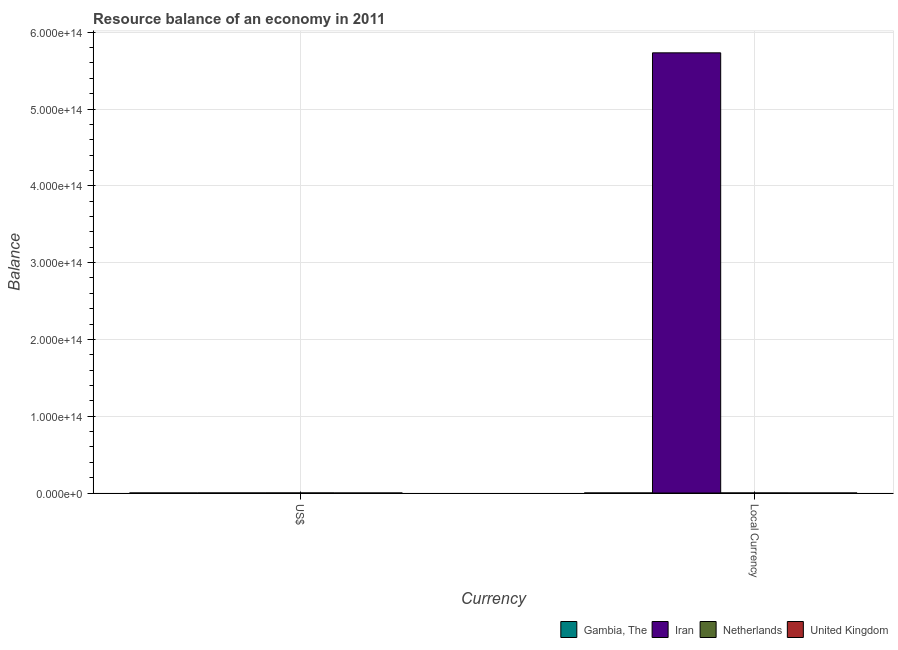How many different coloured bars are there?
Your answer should be very brief. 2. Are the number of bars per tick equal to the number of legend labels?
Your response must be concise. No. Are the number of bars on each tick of the X-axis equal?
Your answer should be compact. Yes. How many bars are there on the 1st tick from the left?
Give a very brief answer. 2. How many bars are there on the 1st tick from the right?
Your answer should be very brief. 2. What is the label of the 2nd group of bars from the left?
Offer a terse response. Local Currency. What is the resource balance in us$ in United Kingdom?
Give a very brief answer. 0. Across all countries, what is the maximum resource balance in constant us$?
Your answer should be compact. 5.73e+14. Across all countries, what is the minimum resource balance in constant us$?
Your response must be concise. 0. What is the total resource balance in constant us$ in the graph?
Offer a terse response. 5.73e+14. What is the difference between the resource balance in us$ in Iran and that in Netherlands?
Offer a very short reply. -2.23e+1. What is the difference between the resource balance in constant us$ in Netherlands and the resource balance in us$ in United Kingdom?
Provide a short and direct response. 5.49e+1. What is the average resource balance in constant us$ per country?
Your response must be concise. 1.43e+14. What is the difference between the resource balance in us$ and resource balance in constant us$ in Iran?
Your answer should be very brief. -5.73e+14. In how many countries, is the resource balance in us$ greater than 560000000000000 units?
Your answer should be compact. 0. What is the ratio of the resource balance in constant us$ in Iran to that in Netherlands?
Offer a very short reply. 1.04e+04. Are all the bars in the graph horizontal?
Make the answer very short. No. How many countries are there in the graph?
Give a very brief answer. 4. What is the difference between two consecutive major ticks on the Y-axis?
Offer a very short reply. 1.00e+14. Does the graph contain grids?
Offer a very short reply. Yes. How many legend labels are there?
Offer a terse response. 4. How are the legend labels stacked?
Provide a succinct answer. Horizontal. What is the title of the graph?
Provide a short and direct response. Resource balance of an economy in 2011. What is the label or title of the X-axis?
Ensure brevity in your answer.  Currency. What is the label or title of the Y-axis?
Your answer should be very brief. Balance. What is the Balance in Iran in US$?
Provide a succinct answer. 5.40e+1. What is the Balance of Netherlands in US$?
Offer a terse response. 7.63e+1. What is the Balance of United Kingdom in US$?
Ensure brevity in your answer.  0. What is the Balance in Iran in Local Currency?
Make the answer very short. 5.73e+14. What is the Balance in Netherlands in Local Currency?
Your answer should be compact. 5.49e+1. Across all Currency, what is the maximum Balance in Iran?
Your answer should be very brief. 5.73e+14. Across all Currency, what is the maximum Balance in Netherlands?
Provide a short and direct response. 7.63e+1. Across all Currency, what is the minimum Balance in Iran?
Your answer should be very brief. 5.40e+1. Across all Currency, what is the minimum Balance in Netherlands?
Ensure brevity in your answer.  5.49e+1. What is the total Balance of Iran in the graph?
Your answer should be very brief. 5.73e+14. What is the total Balance in Netherlands in the graph?
Offer a terse response. 1.31e+11. What is the difference between the Balance of Iran in US$ and that in Local Currency?
Provide a succinct answer. -5.73e+14. What is the difference between the Balance of Netherlands in US$ and that in Local Currency?
Offer a terse response. 2.14e+1. What is the difference between the Balance of Iran in US$ and the Balance of Netherlands in Local Currency?
Your answer should be very brief. -9.16e+08. What is the average Balance in Gambia, The per Currency?
Provide a short and direct response. 0. What is the average Balance of Iran per Currency?
Offer a terse response. 2.87e+14. What is the average Balance in Netherlands per Currency?
Provide a short and direct response. 6.56e+1. What is the average Balance in United Kingdom per Currency?
Offer a very short reply. 0. What is the difference between the Balance of Iran and Balance of Netherlands in US$?
Your answer should be compact. -2.23e+1. What is the difference between the Balance in Iran and Balance in Netherlands in Local Currency?
Offer a very short reply. 5.73e+14. What is the ratio of the Balance of Iran in US$ to that in Local Currency?
Your answer should be compact. 0. What is the ratio of the Balance in Netherlands in US$ to that in Local Currency?
Make the answer very short. 1.39. What is the difference between the highest and the second highest Balance in Iran?
Keep it short and to the point. 5.73e+14. What is the difference between the highest and the second highest Balance in Netherlands?
Provide a succinct answer. 2.14e+1. What is the difference between the highest and the lowest Balance in Iran?
Your answer should be very brief. 5.73e+14. What is the difference between the highest and the lowest Balance in Netherlands?
Your answer should be very brief. 2.14e+1. 